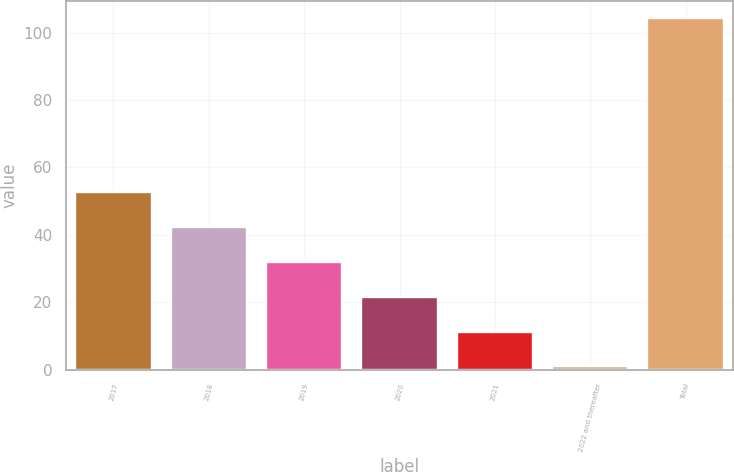Convert chart to OTSL. <chart><loc_0><loc_0><loc_500><loc_500><bar_chart><fcel>2017<fcel>2018<fcel>2019<fcel>2020<fcel>2021<fcel>2022 and thereafter<fcel>Total<nl><fcel>52.65<fcel>42.32<fcel>31.99<fcel>21.66<fcel>11.33<fcel>1<fcel>104.3<nl></chart> 